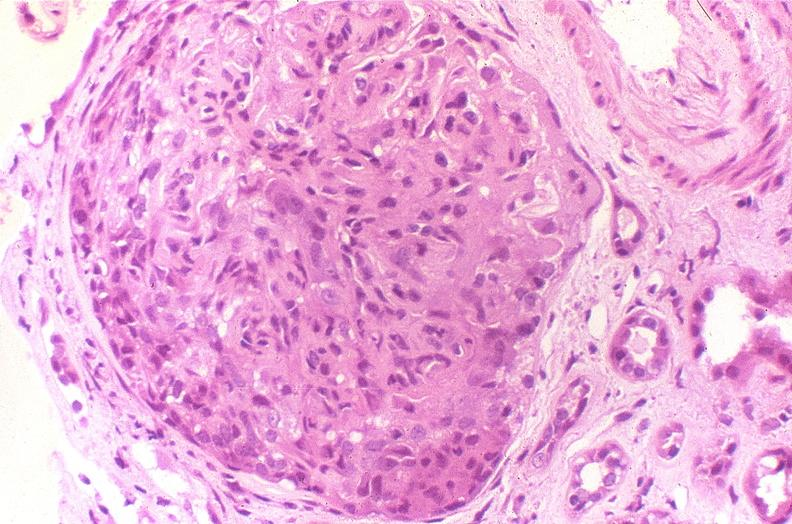what is present?
Answer the question using a single word or phrase. Urinary 